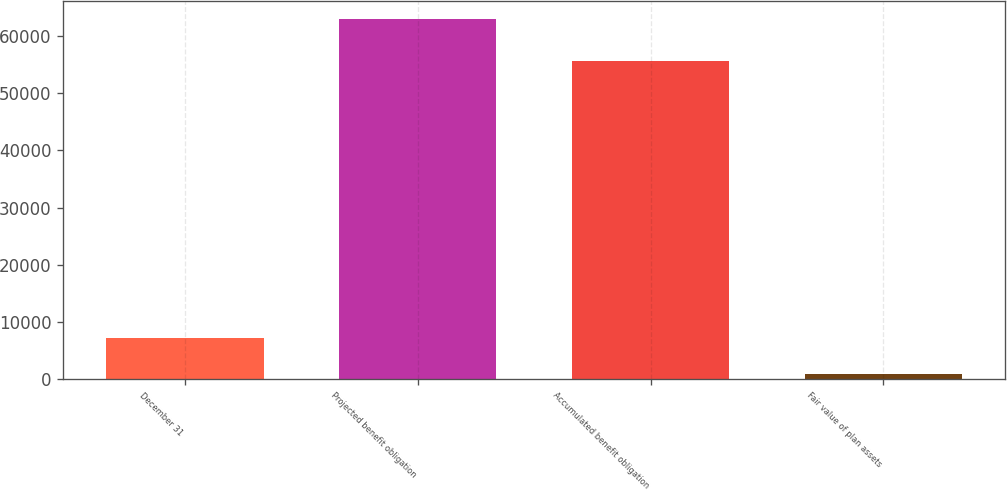Convert chart. <chart><loc_0><loc_0><loc_500><loc_500><bar_chart><fcel>December 31<fcel>Projected benefit obligation<fcel>Accumulated benefit obligation<fcel>Fair value of plan assets<nl><fcel>7180.7<fcel>63014<fcel>55623<fcel>977<nl></chart> 